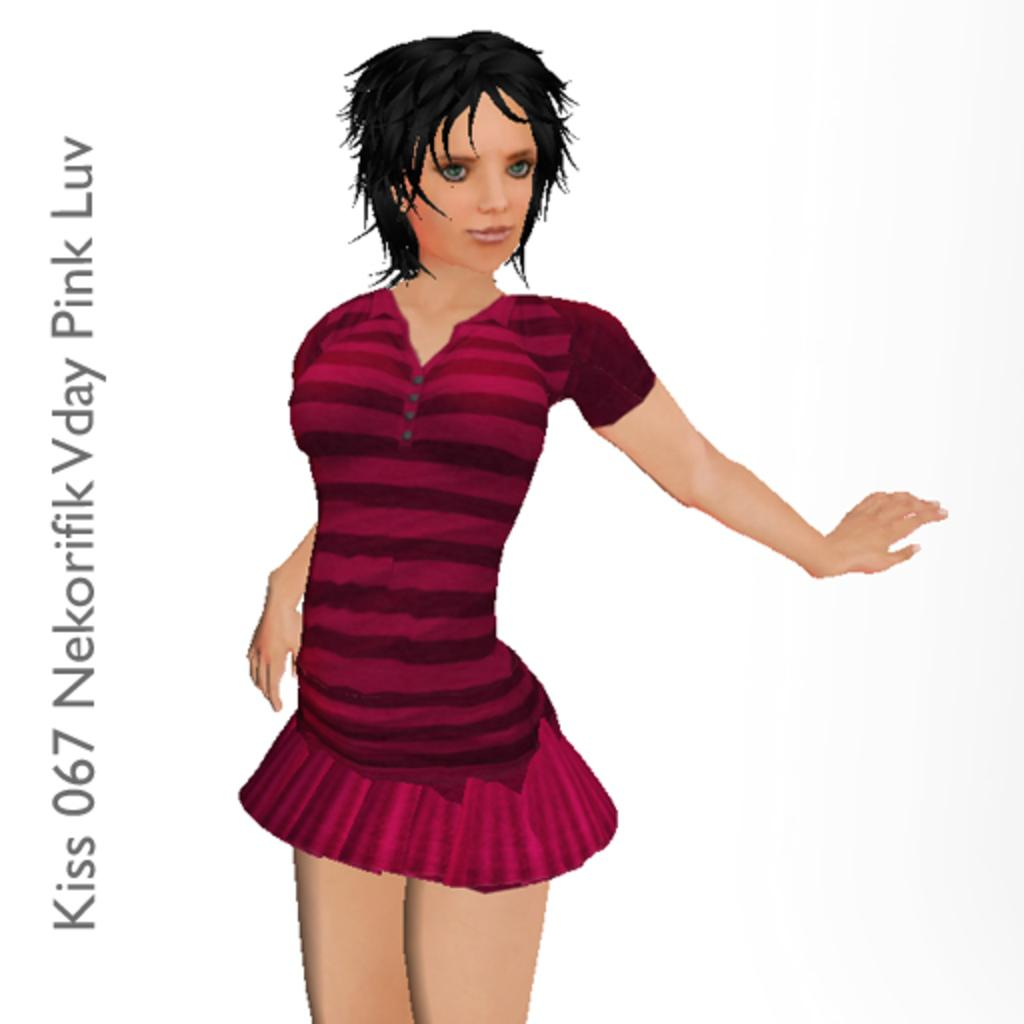What style is the image drawn in? The image is an anime depiction. Who is the main character in the image? There is a girl in the image. What is the girl wearing? The girl is wearing a pink dress. Where can text be found in the image? There is text on the left side of the image. How many dolls are sitting on the girl's shoulder in the image? There are no dolls present in the image. What type of sign is the girl holding in the image? The girl is not holding a sign in the image. 